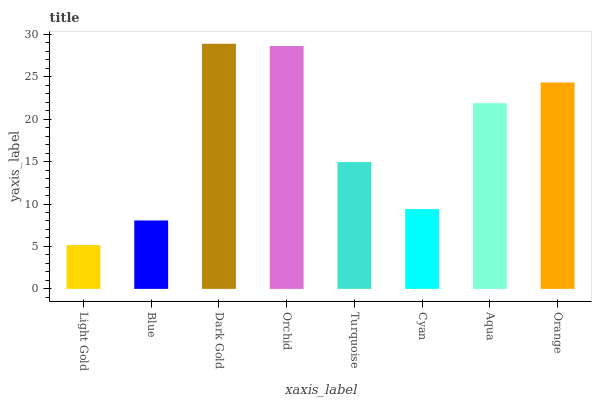Is Light Gold the minimum?
Answer yes or no. Yes. Is Dark Gold the maximum?
Answer yes or no. Yes. Is Blue the minimum?
Answer yes or no. No. Is Blue the maximum?
Answer yes or no. No. Is Blue greater than Light Gold?
Answer yes or no. Yes. Is Light Gold less than Blue?
Answer yes or no. Yes. Is Light Gold greater than Blue?
Answer yes or no. No. Is Blue less than Light Gold?
Answer yes or no. No. Is Aqua the high median?
Answer yes or no. Yes. Is Turquoise the low median?
Answer yes or no. Yes. Is Orchid the high median?
Answer yes or no. No. Is Cyan the low median?
Answer yes or no. No. 